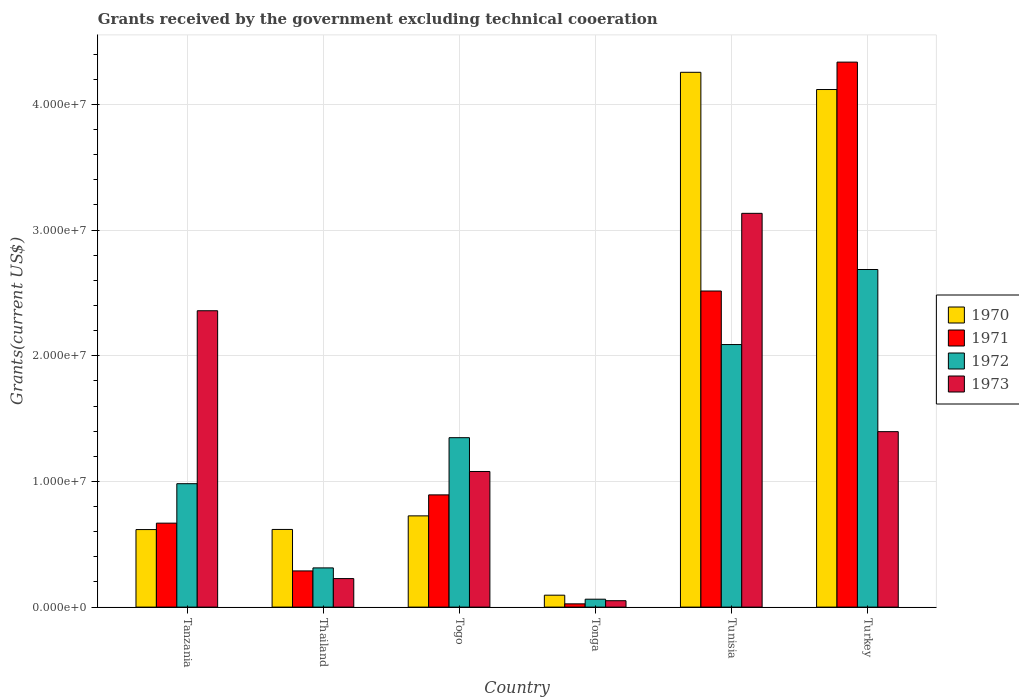How many different coloured bars are there?
Ensure brevity in your answer.  4. Are the number of bars per tick equal to the number of legend labels?
Keep it short and to the point. Yes. How many bars are there on the 2nd tick from the left?
Offer a terse response. 4. How many bars are there on the 5th tick from the right?
Provide a succinct answer. 4. What is the label of the 3rd group of bars from the left?
Keep it short and to the point. Togo. In how many cases, is the number of bars for a given country not equal to the number of legend labels?
Your answer should be very brief. 0. What is the total grants received by the government in 1971 in Tunisia?
Offer a terse response. 2.52e+07. Across all countries, what is the maximum total grants received by the government in 1971?
Your response must be concise. 4.34e+07. Across all countries, what is the minimum total grants received by the government in 1970?
Your response must be concise. 9.50e+05. In which country was the total grants received by the government in 1970 maximum?
Provide a succinct answer. Tunisia. In which country was the total grants received by the government in 1973 minimum?
Ensure brevity in your answer.  Tonga. What is the total total grants received by the government in 1970 in the graph?
Offer a terse response. 1.04e+08. What is the difference between the total grants received by the government in 1971 in Thailand and that in Tunisia?
Offer a very short reply. -2.23e+07. What is the difference between the total grants received by the government in 1970 in Tonga and the total grants received by the government in 1971 in Tunisia?
Your answer should be compact. -2.42e+07. What is the average total grants received by the government in 1973 per country?
Provide a succinct answer. 1.37e+07. In how many countries, is the total grants received by the government in 1970 greater than 30000000 US$?
Your response must be concise. 2. What is the ratio of the total grants received by the government in 1972 in Tanzania to that in Togo?
Your answer should be compact. 0.73. What is the difference between the highest and the second highest total grants received by the government in 1973?
Keep it short and to the point. 1.74e+07. What is the difference between the highest and the lowest total grants received by the government in 1971?
Your answer should be very brief. 4.31e+07. In how many countries, is the total grants received by the government in 1971 greater than the average total grants received by the government in 1971 taken over all countries?
Your answer should be compact. 2. Is it the case that in every country, the sum of the total grants received by the government in 1973 and total grants received by the government in 1972 is greater than the sum of total grants received by the government in 1970 and total grants received by the government in 1971?
Offer a very short reply. No. What does the 1st bar from the right in Tanzania represents?
Offer a terse response. 1973. Is it the case that in every country, the sum of the total grants received by the government in 1970 and total grants received by the government in 1971 is greater than the total grants received by the government in 1973?
Keep it short and to the point. No. How many bars are there?
Keep it short and to the point. 24. How many countries are there in the graph?
Offer a terse response. 6. Are the values on the major ticks of Y-axis written in scientific E-notation?
Give a very brief answer. Yes. Does the graph contain any zero values?
Offer a very short reply. No. How are the legend labels stacked?
Your answer should be very brief. Vertical. What is the title of the graph?
Offer a very short reply. Grants received by the government excluding technical cooeration. What is the label or title of the Y-axis?
Keep it short and to the point. Grants(current US$). What is the Grants(current US$) of 1970 in Tanzania?
Give a very brief answer. 6.17e+06. What is the Grants(current US$) in 1971 in Tanzania?
Keep it short and to the point. 6.68e+06. What is the Grants(current US$) in 1972 in Tanzania?
Your answer should be compact. 9.82e+06. What is the Grants(current US$) in 1973 in Tanzania?
Make the answer very short. 2.36e+07. What is the Grants(current US$) in 1970 in Thailand?
Your answer should be compact. 6.18e+06. What is the Grants(current US$) in 1971 in Thailand?
Ensure brevity in your answer.  2.88e+06. What is the Grants(current US$) in 1972 in Thailand?
Your response must be concise. 3.12e+06. What is the Grants(current US$) in 1973 in Thailand?
Provide a short and direct response. 2.27e+06. What is the Grants(current US$) of 1970 in Togo?
Make the answer very short. 7.26e+06. What is the Grants(current US$) of 1971 in Togo?
Give a very brief answer. 8.93e+06. What is the Grants(current US$) in 1972 in Togo?
Offer a very short reply. 1.35e+07. What is the Grants(current US$) in 1973 in Togo?
Offer a terse response. 1.08e+07. What is the Grants(current US$) of 1970 in Tonga?
Offer a terse response. 9.50e+05. What is the Grants(current US$) in 1971 in Tonga?
Your answer should be compact. 2.60e+05. What is the Grants(current US$) of 1972 in Tonga?
Keep it short and to the point. 6.30e+05. What is the Grants(current US$) of 1973 in Tonga?
Your response must be concise. 5.10e+05. What is the Grants(current US$) in 1970 in Tunisia?
Ensure brevity in your answer.  4.26e+07. What is the Grants(current US$) in 1971 in Tunisia?
Your answer should be very brief. 2.52e+07. What is the Grants(current US$) in 1972 in Tunisia?
Give a very brief answer. 2.09e+07. What is the Grants(current US$) of 1973 in Tunisia?
Offer a terse response. 3.13e+07. What is the Grants(current US$) in 1970 in Turkey?
Provide a succinct answer. 4.12e+07. What is the Grants(current US$) in 1971 in Turkey?
Your response must be concise. 4.34e+07. What is the Grants(current US$) of 1972 in Turkey?
Offer a very short reply. 2.69e+07. What is the Grants(current US$) of 1973 in Turkey?
Offer a very short reply. 1.40e+07. Across all countries, what is the maximum Grants(current US$) of 1970?
Keep it short and to the point. 4.26e+07. Across all countries, what is the maximum Grants(current US$) in 1971?
Make the answer very short. 4.34e+07. Across all countries, what is the maximum Grants(current US$) of 1972?
Make the answer very short. 2.69e+07. Across all countries, what is the maximum Grants(current US$) in 1973?
Offer a very short reply. 3.13e+07. Across all countries, what is the minimum Grants(current US$) in 1970?
Offer a very short reply. 9.50e+05. Across all countries, what is the minimum Grants(current US$) in 1972?
Your answer should be compact. 6.30e+05. Across all countries, what is the minimum Grants(current US$) in 1973?
Your answer should be compact. 5.10e+05. What is the total Grants(current US$) of 1970 in the graph?
Your answer should be very brief. 1.04e+08. What is the total Grants(current US$) of 1971 in the graph?
Ensure brevity in your answer.  8.73e+07. What is the total Grants(current US$) of 1972 in the graph?
Your response must be concise. 7.48e+07. What is the total Grants(current US$) of 1973 in the graph?
Offer a very short reply. 8.24e+07. What is the difference between the Grants(current US$) of 1971 in Tanzania and that in Thailand?
Your response must be concise. 3.80e+06. What is the difference between the Grants(current US$) of 1972 in Tanzania and that in Thailand?
Provide a succinct answer. 6.70e+06. What is the difference between the Grants(current US$) in 1973 in Tanzania and that in Thailand?
Offer a terse response. 2.13e+07. What is the difference between the Grants(current US$) of 1970 in Tanzania and that in Togo?
Your answer should be compact. -1.09e+06. What is the difference between the Grants(current US$) of 1971 in Tanzania and that in Togo?
Keep it short and to the point. -2.25e+06. What is the difference between the Grants(current US$) of 1972 in Tanzania and that in Togo?
Ensure brevity in your answer.  -3.66e+06. What is the difference between the Grants(current US$) in 1973 in Tanzania and that in Togo?
Your response must be concise. 1.28e+07. What is the difference between the Grants(current US$) in 1970 in Tanzania and that in Tonga?
Your response must be concise. 5.22e+06. What is the difference between the Grants(current US$) of 1971 in Tanzania and that in Tonga?
Keep it short and to the point. 6.42e+06. What is the difference between the Grants(current US$) of 1972 in Tanzania and that in Tonga?
Your answer should be compact. 9.19e+06. What is the difference between the Grants(current US$) of 1973 in Tanzania and that in Tonga?
Keep it short and to the point. 2.31e+07. What is the difference between the Grants(current US$) in 1970 in Tanzania and that in Tunisia?
Provide a succinct answer. -3.64e+07. What is the difference between the Grants(current US$) of 1971 in Tanzania and that in Tunisia?
Your answer should be very brief. -1.85e+07. What is the difference between the Grants(current US$) in 1972 in Tanzania and that in Tunisia?
Offer a terse response. -1.11e+07. What is the difference between the Grants(current US$) of 1973 in Tanzania and that in Tunisia?
Your answer should be very brief. -7.75e+06. What is the difference between the Grants(current US$) in 1970 in Tanzania and that in Turkey?
Offer a terse response. -3.50e+07. What is the difference between the Grants(current US$) of 1971 in Tanzania and that in Turkey?
Offer a terse response. -3.67e+07. What is the difference between the Grants(current US$) in 1972 in Tanzania and that in Turkey?
Provide a short and direct response. -1.70e+07. What is the difference between the Grants(current US$) in 1973 in Tanzania and that in Turkey?
Provide a succinct answer. 9.62e+06. What is the difference between the Grants(current US$) of 1970 in Thailand and that in Togo?
Your answer should be compact. -1.08e+06. What is the difference between the Grants(current US$) in 1971 in Thailand and that in Togo?
Your answer should be very brief. -6.05e+06. What is the difference between the Grants(current US$) in 1972 in Thailand and that in Togo?
Your answer should be very brief. -1.04e+07. What is the difference between the Grants(current US$) of 1973 in Thailand and that in Togo?
Your answer should be very brief. -8.52e+06. What is the difference between the Grants(current US$) of 1970 in Thailand and that in Tonga?
Provide a short and direct response. 5.23e+06. What is the difference between the Grants(current US$) of 1971 in Thailand and that in Tonga?
Provide a succinct answer. 2.62e+06. What is the difference between the Grants(current US$) of 1972 in Thailand and that in Tonga?
Offer a terse response. 2.49e+06. What is the difference between the Grants(current US$) in 1973 in Thailand and that in Tonga?
Provide a short and direct response. 1.76e+06. What is the difference between the Grants(current US$) in 1970 in Thailand and that in Tunisia?
Your response must be concise. -3.64e+07. What is the difference between the Grants(current US$) in 1971 in Thailand and that in Tunisia?
Your response must be concise. -2.23e+07. What is the difference between the Grants(current US$) in 1972 in Thailand and that in Tunisia?
Provide a succinct answer. -1.78e+07. What is the difference between the Grants(current US$) of 1973 in Thailand and that in Tunisia?
Keep it short and to the point. -2.91e+07. What is the difference between the Grants(current US$) in 1970 in Thailand and that in Turkey?
Offer a very short reply. -3.50e+07. What is the difference between the Grants(current US$) of 1971 in Thailand and that in Turkey?
Provide a short and direct response. -4.05e+07. What is the difference between the Grants(current US$) in 1972 in Thailand and that in Turkey?
Your answer should be very brief. -2.37e+07. What is the difference between the Grants(current US$) of 1973 in Thailand and that in Turkey?
Your answer should be compact. -1.17e+07. What is the difference between the Grants(current US$) in 1970 in Togo and that in Tonga?
Offer a very short reply. 6.31e+06. What is the difference between the Grants(current US$) in 1971 in Togo and that in Tonga?
Offer a very short reply. 8.67e+06. What is the difference between the Grants(current US$) in 1972 in Togo and that in Tonga?
Make the answer very short. 1.28e+07. What is the difference between the Grants(current US$) in 1973 in Togo and that in Tonga?
Your answer should be compact. 1.03e+07. What is the difference between the Grants(current US$) in 1970 in Togo and that in Tunisia?
Your answer should be very brief. -3.53e+07. What is the difference between the Grants(current US$) of 1971 in Togo and that in Tunisia?
Give a very brief answer. -1.62e+07. What is the difference between the Grants(current US$) of 1972 in Togo and that in Tunisia?
Give a very brief answer. -7.41e+06. What is the difference between the Grants(current US$) in 1973 in Togo and that in Tunisia?
Your answer should be very brief. -2.05e+07. What is the difference between the Grants(current US$) of 1970 in Togo and that in Turkey?
Give a very brief answer. -3.39e+07. What is the difference between the Grants(current US$) of 1971 in Togo and that in Turkey?
Provide a short and direct response. -3.44e+07. What is the difference between the Grants(current US$) in 1972 in Togo and that in Turkey?
Make the answer very short. -1.34e+07. What is the difference between the Grants(current US$) in 1973 in Togo and that in Turkey?
Your answer should be very brief. -3.17e+06. What is the difference between the Grants(current US$) of 1970 in Tonga and that in Tunisia?
Ensure brevity in your answer.  -4.16e+07. What is the difference between the Grants(current US$) of 1971 in Tonga and that in Tunisia?
Your answer should be very brief. -2.49e+07. What is the difference between the Grants(current US$) in 1972 in Tonga and that in Tunisia?
Provide a succinct answer. -2.03e+07. What is the difference between the Grants(current US$) in 1973 in Tonga and that in Tunisia?
Your answer should be very brief. -3.08e+07. What is the difference between the Grants(current US$) of 1970 in Tonga and that in Turkey?
Make the answer very short. -4.02e+07. What is the difference between the Grants(current US$) in 1971 in Tonga and that in Turkey?
Offer a terse response. -4.31e+07. What is the difference between the Grants(current US$) of 1972 in Tonga and that in Turkey?
Your answer should be very brief. -2.62e+07. What is the difference between the Grants(current US$) of 1973 in Tonga and that in Turkey?
Provide a succinct answer. -1.34e+07. What is the difference between the Grants(current US$) of 1970 in Tunisia and that in Turkey?
Give a very brief answer. 1.37e+06. What is the difference between the Grants(current US$) of 1971 in Tunisia and that in Turkey?
Ensure brevity in your answer.  -1.82e+07. What is the difference between the Grants(current US$) in 1972 in Tunisia and that in Turkey?
Make the answer very short. -5.97e+06. What is the difference between the Grants(current US$) of 1973 in Tunisia and that in Turkey?
Offer a very short reply. 1.74e+07. What is the difference between the Grants(current US$) of 1970 in Tanzania and the Grants(current US$) of 1971 in Thailand?
Offer a very short reply. 3.29e+06. What is the difference between the Grants(current US$) of 1970 in Tanzania and the Grants(current US$) of 1972 in Thailand?
Make the answer very short. 3.05e+06. What is the difference between the Grants(current US$) of 1970 in Tanzania and the Grants(current US$) of 1973 in Thailand?
Ensure brevity in your answer.  3.90e+06. What is the difference between the Grants(current US$) of 1971 in Tanzania and the Grants(current US$) of 1972 in Thailand?
Offer a terse response. 3.56e+06. What is the difference between the Grants(current US$) in 1971 in Tanzania and the Grants(current US$) in 1973 in Thailand?
Your answer should be very brief. 4.41e+06. What is the difference between the Grants(current US$) in 1972 in Tanzania and the Grants(current US$) in 1973 in Thailand?
Keep it short and to the point. 7.55e+06. What is the difference between the Grants(current US$) of 1970 in Tanzania and the Grants(current US$) of 1971 in Togo?
Keep it short and to the point. -2.76e+06. What is the difference between the Grants(current US$) in 1970 in Tanzania and the Grants(current US$) in 1972 in Togo?
Ensure brevity in your answer.  -7.31e+06. What is the difference between the Grants(current US$) of 1970 in Tanzania and the Grants(current US$) of 1973 in Togo?
Make the answer very short. -4.62e+06. What is the difference between the Grants(current US$) in 1971 in Tanzania and the Grants(current US$) in 1972 in Togo?
Your answer should be very brief. -6.80e+06. What is the difference between the Grants(current US$) in 1971 in Tanzania and the Grants(current US$) in 1973 in Togo?
Provide a succinct answer. -4.11e+06. What is the difference between the Grants(current US$) in 1972 in Tanzania and the Grants(current US$) in 1973 in Togo?
Offer a terse response. -9.70e+05. What is the difference between the Grants(current US$) in 1970 in Tanzania and the Grants(current US$) in 1971 in Tonga?
Offer a terse response. 5.91e+06. What is the difference between the Grants(current US$) of 1970 in Tanzania and the Grants(current US$) of 1972 in Tonga?
Give a very brief answer. 5.54e+06. What is the difference between the Grants(current US$) of 1970 in Tanzania and the Grants(current US$) of 1973 in Tonga?
Your answer should be compact. 5.66e+06. What is the difference between the Grants(current US$) in 1971 in Tanzania and the Grants(current US$) in 1972 in Tonga?
Offer a very short reply. 6.05e+06. What is the difference between the Grants(current US$) in 1971 in Tanzania and the Grants(current US$) in 1973 in Tonga?
Provide a succinct answer. 6.17e+06. What is the difference between the Grants(current US$) of 1972 in Tanzania and the Grants(current US$) of 1973 in Tonga?
Ensure brevity in your answer.  9.31e+06. What is the difference between the Grants(current US$) of 1970 in Tanzania and the Grants(current US$) of 1971 in Tunisia?
Give a very brief answer. -1.90e+07. What is the difference between the Grants(current US$) of 1970 in Tanzania and the Grants(current US$) of 1972 in Tunisia?
Keep it short and to the point. -1.47e+07. What is the difference between the Grants(current US$) of 1970 in Tanzania and the Grants(current US$) of 1973 in Tunisia?
Ensure brevity in your answer.  -2.52e+07. What is the difference between the Grants(current US$) in 1971 in Tanzania and the Grants(current US$) in 1972 in Tunisia?
Provide a short and direct response. -1.42e+07. What is the difference between the Grants(current US$) in 1971 in Tanzania and the Grants(current US$) in 1973 in Tunisia?
Provide a short and direct response. -2.46e+07. What is the difference between the Grants(current US$) in 1972 in Tanzania and the Grants(current US$) in 1973 in Tunisia?
Offer a terse response. -2.15e+07. What is the difference between the Grants(current US$) in 1970 in Tanzania and the Grants(current US$) in 1971 in Turkey?
Keep it short and to the point. -3.72e+07. What is the difference between the Grants(current US$) in 1970 in Tanzania and the Grants(current US$) in 1972 in Turkey?
Your answer should be compact. -2.07e+07. What is the difference between the Grants(current US$) of 1970 in Tanzania and the Grants(current US$) of 1973 in Turkey?
Provide a short and direct response. -7.79e+06. What is the difference between the Grants(current US$) in 1971 in Tanzania and the Grants(current US$) in 1972 in Turkey?
Keep it short and to the point. -2.02e+07. What is the difference between the Grants(current US$) of 1971 in Tanzania and the Grants(current US$) of 1973 in Turkey?
Offer a very short reply. -7.28e+06. What is the difference between the Grants(current US$) in 1972 in Tanzania and the Grants(current US$) in 1973 in Turkey?
Offer a terse response. -4.14e+06. What is the difference between the Grants(current US$) of 1970 in Thailand and the Grants(current US$) of 1971 in Togo?
Provide a succinct answer. -2.75e+06. What is the difference between the Grants(current US$) of 1970 in Thailand and the Grants(current US$) of 1972 in Togo?
Keep it short and to the point. -7.30e+06. What is the difference between the Grants(current US$) in 1970 in Thailand and the Grants(current US$) in 1973 in Togo?
Your response must be concise. -4.61e+06. What is the difference between the Grants(current US$) of 1971 in Thailand and the Grants(current US$) of 1972 in Togo?
Keep it short and to the point. -1.06e+07. What is the difference between the Grants(current US$) of 1971 in Thailand and the Grants(current US$) of 1973 in Togo?
Your answer should be compact. -7.91e+06. What is the difference between the Grants(current US$) in 1972 in Thailand and the Grants(current US$) in 1973 in Togo?
Offer a terse response. -7.67e+06. What is the difference between the Grants(current US$) in 1970 in Thailand and the Grants(current US$) in 1971 in Tonga?
Give a very brief answer. 5.92e+06. What is the difference between the Grants(current US$) in 1970 in Thailand and the Grants(current US$) in 1972 in Tonga?
Ensure brevity in your answer.  5.55e+06. What is the difference between the Grants(current US$) in 1970 in Thailand and the Grants(current US$) in 1973 in Tonga?
Offer a terse response. 5.67e+06. What is the difference between the Grants(current US$) in 1971 in Thailand and the Grants(current US$) in 1972 in Tonga?
Ensure brevity in your answer.  2.25e+06. What is the difference between the Grants(current US$) in 1971 in Thailand and the Grants(current US$) in 1973 in Tonga?
Provide a short and direct response. 2.37e+06. What is the difference between the Grants(current US$) in 1972 in Thailand and the Grants(current US$) in 1973 in Tonga?
Your answer should be very brief. 2.61e+06. What is the difference between the Grants(current US$) in 1970 in Thailand and the Grants(current US$) in 1971 in Tunisia?
Your answer should be very brief. -1.90e+07. What is the difference between the Grants(current US$) of 1970 in Thailand and the Grants(current US$) of 1972 in Tunisia?
Ensure brevity in your answer.  -1.47e+07. What is the difference between the Grants(current US$) of 1970 in Thailand and the Grants(current US$) of 1973 in Tunisia?
Keep it short and to the point. -2.52e+07. What is the difference between the Grants(current US$) in 1971 in Thailand and the Grants(current US$) in 1972 in Tunisia?
Provide a short and direct response. -1.80e+07. What is the difference between the Grants(current US$) in 1971 in Thailand and the Grants(current US$) in 1973 in Tunisia?
Your answer should be compact. -2.84e+07. What is the difference between the Grants(current US$) in 1972 in Thailand and the Grants(current US$) in 1973 in Tunisia?
Your answer should be very brief. -2.82e+07. What is the difference between the Grants(current US$) in 1970 in Thailand and the Grants(current US$) in 1971 in Turkey?
Provide a succinct answer. -3.72e+07. What is the difference between the Grants(current US$) in 1970 in Thailand and the Grants(current US$) in 1972 in Turkey?
Ensure brevity in your answer.  -2.07e+07. What is the difference between the Grants(current US$) in 1970 in Thailand and the Grants(current US$) in 1973 in Turkey?
Your answer should be compact. -7.78e+06. What is the difference between the Grants(current US$) in 1971 in Thailand and the Grants(current US$) in 1972 in Turkey?
Offer a very short reply. -2.40e+07. What is the difference between the Grants(current US$) of 1971 in Thailand and the Grants(current US$) of 1973 in Turkey?
Your response must be concise. -1.11e+07. What is the difference between the Grants(current US$) of 1972 in Thailand and the Grants(current US$) of 1973 in Turkey?
Your response must be concise. -1.08e+07. What is the difference between the Grants(current US$) of 1970 in Togo and the Grants(current US$) of 1972 in Tonga?
Keep it short and to the point. 6.63e+06. What is the difference between the Grants(current US$) in 1970 in Togo and the Grants(current US$) in 1973 in Tonga?
Your response must be concise. 6.75e+06. What is the difference between the Grants(current US$) of 1971 in Togo and the Grants(current US$) of 1972 in Tonga?
Provide a succinct answer. 8.30e+06. What is the difference between the Grants(current US$) in 1971 in Togo and the Grants(current US$) in 1973 in Tonga?
Ensure brevity in your answer.  8.42e+06. What is the difference between the Grants(current US$) in 1972 in Togo and the Grants(current US$) in 1973 in Tonga?
Give a very brief answer. 1.30e+07. What is the difference between the Grants(current US$) of 1970 in Togo and the Grants(current US$) of 1971 in Tunisia?
Your answer should be compact. -1.79e+07. What is the difference between the Grants(current US$) of 1970 in Togo and the Grants(current US$) of 1972 in Tunisia?
Provide a short and direct response. -1.36e+07. What is the difference between the Grants(current US$) of 1970 in Togo and the Grants(current US$) of 1973 in Tunisia?
Your response must be concise. -2.41e+07. What is the difference between the Grants(current US$) in 1971 in Togo and the Grants(current US$) in 1972 in Tunisia?
Provide a succinct answer. -1.20e+07. What is the difference between the Grants(current US$) of 1971 in Togo and the Grants(current US$) of 1973 in Tunisia?
Keep it short and to the point. -2.24e+07. What is the difference between the Grants(current US$) in 1972 in Togo and the Grants(current US$) in 1973 in Tunisia?
Keep it short and to the point. -1.78e+07. What is the difference between the Grants(current US$) of 1970 in Togo and the Grants(current US$) of 1971 in Turkey?
Give a very brief answer. -3.61e+07. What is the difference between the Grants(current US$) of 1970 in Togo and the Grants(current US$) of 1972 in Turkey?
Provide a short and direct response. -1.96e+07. What is the difference between the Grants(current US$) of 1970 in Togo and the Grants(current US$) of 1973 in Turkey?
Your response must be concise. -6.70e+06. What is the difference between the Grants(current US$) of 1971 in Togo and the Grants(current US$) of 1972 in Turkey?
Offer a very short reply. -1.79e+07. What is the difference between the Grants(current US$) of 1971 in Togo and the Grants(current US$) of 1973 in Turkey?
Provide a succinct answer. -5.03e+06. What is the difference between the Grants(current US$) of 1972 in Togo and the Grants(current US$) of 1973 in Turkey?
Provide a short and direct response. -4.80e+05. What is the difference between the Grants(current US$) in 1970 in Tonga and the Grants(current US$) in 1971 in Tunisia?
Your answer should be compact. -2.42e+07. What is the difference between the Grants(current US$) in 1970 in Tonga and the Grants(current US$) in 1972 in Tunisia?
Offer a very short reply. -1.99e+07. What is the difference between the Grants(current US$) in 1970 in Tonga and the Grants(current US$) in 1973 in Tunisia?
Provide a succinct answer. -3.04e+07. What is the difference between the Grants(current US$) of 1971 in Tonga and the Grants(current US$) of 1972 in Tunisia?
Ensure brevity in your answer.  -2.06e+07. What is the difference between the Grants(current US$) of 1971 in Tonga and the Grants(current US$) of 1973 in Tunisia?
Provide a succinct answer. -3.11e+07. What is the difference between the Grants(current US$) of 1972 in Tonga and the Grants(current US$) of 1973 in Tunisia?
Provide a short and direct response. -3.07e+07. What is the difference between the Grants(current US$) of 1970 in Tonga and the Grants(current US$) of 1971 in Turkey?
Your answer should be very brief. -4.24e+07. What is the difference between the Grants(current US$) of 1970 in Tonga and the Grants(current US$) of 1972 in Turkey?
Your response must be concise. -2.59e+07. What is the difference between the Grants(current US$) in 1970 in Tonga and the Grants(current US$) in 1973 in Turkey?
Keep it short and to the point. -1.30e+07. What is the difference between the Grants(current US$) of 1971 in Tonga and the Grants(current US$) of 1972 in Turkey?
Keep it short and to the point. -2.66e+07. What is the difference between the Grants(current US$) in 1971 in Tonga and the Grants(current US$) in 1973 in Turkey?
Provide a succinct answer. -1.37e+07. What is the difference between the Grants(current US$) of 1972 in Tonga and the Grants(current US$) of 1973 in Turkey?
Provide a short and direct response. -1.33e+07. What is the difference between the Grants(current US$) in 1970 in Tunisia and the Grants(current US$) in 1971 in Turkey?
Give a very brief answer. -8.10e+05. What is the difference between the Grants(current US$) of 1970 in Tunisia and the Grants(current US$) of 1972 in Turkey?
Offer a very short reply. 1.57e+07. What is the difference between the Grants(current US$) in 1970 in Tunisia and the Grants(current US$) in 1973 in Turkey?
Your answer should be very brief. 2.86e+07. What is the difference between the Grants(current US$) in 1971 in Tunisia and the Grants(current US$) in 1972 in Turkey?
Your answer should be very brief. -1.71e+06. What is the difference between the Grants(current US$) in 1971 in Tunisia and the Grants(current US$) in 1973 in Turkey?
Offer a terse response. 1.12e+07. What is the difference between the Grants(current US$) of 1972 in Tunisia and the Grants(current US$) of 1973 in Turkey?
Your answer should be very brief. 6.93e+06. What is the average Grants(current US$) of 1970 per country?
Give a very brief answer. 1.74e+07. What is the average Grants(current US$) of 1971 per country?
Make the answer very short. 1.45e+07. What is the average Grants(current US$) of 1972 per country?
Your response must be concise. 1.25e+07. What is the average Grants(current US$) in 1973 per country?
Your answer should be very brief. 1.37e+07. What is the difference between the Grants(current US$) in 1970 and Grants(current US$) in 1971 in Tanzania?
Offer a very short reply. -5.10e+05. What is the difference between the Grants(current US$) in 1970 and Grants(current US$) in 1972 in Tanzania?
Keep it short and to the point. -3.65e+06. What is the difference between the Grants(current US$) in 1970 and Grants(current US$) in 1973 in Tanzania?
Keep it short and to the point. -1.74e+07. What is the difference between the Grants(current US$) in 1971 and Grants(current US$) in 1972 in Tanzania?
Offer a terse response. -3.14e+06. What is the difference between the Grants(current US$) in 1971 and Grants(current US$) in 1973 in Tanzania?
Provide a short and direct response. -1.69e+07. What is the difference between the Grants(current US$) in 1972 and Grants(current US$) in 1973 in Tanzania?
Provide a succinct answer. -1.38e+07. What is the difference between the Grants(current US$) in 1970 and Grants(current US$) in 1971 in Thailand?
Make the answer very short. 3.30e+06. What is the difference between the Grants(current US$) of 1970 and Grants(current US$) of 1972 in Thailand?
Your answer should be very brief. 3.06e+06. What is the difference between the Grants(current US$) in 1970 and Grants(current US$) in 1973 in Thailand?
Your answer should be compact. 3.91e+06. What is the difference between the Grants(current US$) in 1971 and Grants(current US$) in 1973 in Thailand?
Keep it short and to the point. 6.10e+05. What is the difference between the Grants(current US$) of 1972 and Grants(current US$) of 1973 in Thailand?
Offer a very short reply. 8.50e+05. What is the difference between the Grants(current US$) in 1970 and Grants(current US$) in 1971 in Togo?
Offer a very short reply. -1.67e+06. What is the difference between the Grants(current US$) of 1970 and Grants(current US$) of 1972 in Togo?
Ensure brevity in your answer.  -6.22e+06. What is the difference between the Grants(current US$) in 1970 and Grants(current US$) in 1973 in Togo?
Provide a succinct answer. -3.53e+06. What is the difference between the Grants(current US$) in 1971 and Grants(current US$) in 1972 in Togo?
Ensure brevity in your answer.  -4.55e+06. What is the difference between the Grants(current US$) of 1971 and Grants(current US$) of 1973 in Togo?
Your answer should be compact. -1.86e+06. What is the difference between the Grants(current US$) of 1972 and Grants(current US$) of 1973 in Togo?
Provide a short and direct response. 2.69e+06. What is the difference between the Grants(current US$) of 1970 and Grants(current US$) of 1971 in Tonga?
Offer a terse response. 6.90e+05. What is the difference between the Grants(current US$) in 1970 and Grants(current US$) in 1972 in Tonga?
Your response must be concise. 3.20e+05. What is the difference between the Grants(current US$) of 1971 and Grants(current US$) of 1972 in Tonga?
Your response must be concise. -3.70e+05. What is the difference between the Grants(current US$) of 1971 and Grants(current US$) of 1973 in Tonga?
Give a very brief answer. -2.50e+05. What is the difference between the Grants(current US$) in 1970 and Grants(current US$) in 1971 in Tunisia?
Make the answer very short. 1.74e+07. What is the difference between the Grants(current US$) of 1970 and Grants(current US$) of 1972 in Tunisia?
Offer a terse response. 2.17e+07. What is the difference between the Grants(current US$) in 1970 and Grants(current US$) in 1973 in Tunisia?
Your answer should be compact. 1.12e+07. What is the difference between the Grants(current US$) in 1971 and Grants(current US$) in 1972 in Tunisia?
Keep it short and to the point. 4.26e+06. What is the difference between the Grants(current US$) in 1971 and Grants(current US$) in 1973 in Tunisia?
Give a very brief answer. -6.18e+06. What is the difference between the Grants(current US$) in 1972 and Grants(current US$) in 1973 in Tunisia?
Provide a short and direct response. -1.04e+07. What is the difference between the Grants(current US$) of 1970 and Grants(current US$) of 1971 in Turkey?
Offer a very short reply. -2.18e+06. What is the difference between the Grants(current US$) of 1970 and Grants(current US$) of 1972 in Turkey?
Your answer should be very brief. 1.43e+07. What is the difference between the Grants(current US$) of 1970 and Grants(current US$) of 1973 in Turkey?
Ensure brevity in your answer.  2.72e+07. What is the difference between the Grants(current US$) in 1971 and Grants(current US$) in 1972 in Turkey?
Offer a terse response. 1.65e+07. What is the difference between the Grants(current US$) in 1971 and Grants(current US$) in 1973 in Turkey?
Offer a terse response. 2.94e+07. What is the difference between the Grants(current US$) of 1972 and Grants(current US$) of 1973 in Turkey?
Your answer should be very brief. 1.29e+07. What is the ratio of the Grants(current US$) of 1971 in Tanzania to that in Thailand?
Give a very brief answer. 2.32. What is the ratio of the Grants(current US$) in 1972 in Tanzania to that in Thailand?
Your response must be concise. 3.15. What is the ratio of the Grants(current US$) of 1973 in Tanzania to that in Thailand?
Your answer should be compact. 10.39. What is the ratio of the Grants(current US$) of 1970 in Tanzania to that in Togo?
Offer a terse response. 0.85. What is the ratio of the Grants(current US$) in 1971 in Tanzania to that in Togo?
Ensure brevity in your answer.  0.75. What is the ratio of the Grants(current US$) in 1972 in Tanzania to that in Togo?
Keep it short and to the point. 0.73. What is the ratio of the Grants(current US$) in 1973 in Tanzania to that in Togo?
Your response must be concise. 2.19. What is the ratio of the Grants(current US$) of 1970 in Tanzania to that in Tonga?
Offer a terse response. 6.49. What is the ratio of the Grants(current US$) of 1971 in Tanzania to that in Tonga?
Give a very brief answer. 25.69. What is the ratio of the Grants(current US$) in 1972 in Tanzania to that in Tonga?
Your answer should be compact. 15.59. What is the ratio of the Grants(current US$) in 1973 in Tanzania to that in Tonga?
Keep it short and to the point. 46.24. What is the ratio of the Grants(current US$) in 1970 in Tanzania to that in Tunisia?
Your answer should be compact. 0.14. What is the ratio of the Grants(current US$) of 1971 in Tanzania to that in Tunisia?
Offer a very short reply. 0.27. What is the ratio of the Grants(current US$) in 1972 in Tanzania to that in Tunisia?
Your response must be concise. 0.47. What is the ratio of the Grants(current US$) of 1973 in Tanzania to that in Tunisia?
Provide a succinct answer. 0.75. What is the ratio of the Grants(current US$) in 1970 in Tanzania to that in Turkey?
Offer a terse response. 0.15. What is the ratio of the Grants(current US$) of 1971 in Tanzania to that in Turkey?
Ensure brevity in your answer.  0.15. What is the ratio of the Grants(current US$) of 1972 in Tanzania to that in Turkey?
Make the answer very short. 0.37. What is the ratio of the Grants(current US$) in 1973 in Tanzania to that in Turkey?
Your answer should be very brief. 1.69. What is the ratio of the Grants(current US$) in 1970 in Thailand to that in Togo?
Ensure brevity in your answer.  0.85. What is the ratio of the Grants(current US$) of 1971 in Thailand to that in Togo?
Offer a terse response. 0.32. What is the ratio of the Grants(current US$) of 1972 in Thailand to that in Togo?
Offer a very short reply. 0.23. What is the ratio of the Grants(current US$) in 1973 in Thailand to that in Togo?
Your answer should be very brief. 0.21. What is the ratio of the Grants(current US$) of 1970 in Thailand to that in Tonga?
Give a very brief answer. 6.51. What is the ratio of the Grants(current US$) in 1971 in Thailand to that in Tonga?
Offer a terse response. 11.08. What is the ratio of the Grants(current US$) of 1972 in Thailand to that in Tonga?
Provide a short and direct response. 4.95. What is the ratio of the Grants(current US$) of 1973 in Thailand to that in Tonga?
Your response must be concise. 4.45. What is the ratio of the Grants(current US$) in 1970 in Thailand to that in Tunisia?
Keep it short and to the point. 0.15. What is the ratio of the Grants(current US$) of 1971 in Thailand to that in Tunisia?
Make the answer very short. 0.11. What is the ratio of the Grants(current US$) of 1972 in Thailand to that in Tunisia?
Your response must be concise. 0.15. What is the ratio of the Grants(current US$) of 1973 in Thailand to that in Tunisia?
Provide a succinct answer. 0.07. What is the ratio of the Grants(current US$) in 1970 in Thailand to that in Turkey?
Your response must be concise. 0.15. What is the ratio of the Grants(current US$) in 1971 in Thailand to that in Turkey?
Give a very brief answer. 0.07. What is the ratio of the Grants(current US$) in 1972 in Thailand to that in Turkey?
Your answer should be very brief. 0.12. What is the ratio of the Grants(current US$) in 1973 in Thailand to that in Turkey?
Keep it short and to the point. 0.16. What is the ratio of the Grants(current US$) in 1970 in Togo to that in Tonga?
Your answer should be very brief. 7.64. What is the ratio of the Grants(current US$) in 1971 in Togo to that in Tonga?
Keep it short and to the point. 34.35. What is the ratio of the Grants(current US$) in 1972 in Togo to that in Tonga?
Offer a terse response. 21.4. What is the ratio of the Grants(current US$) in 1973 in Togo to that in Tonga?
Provide a short and direct response. 21.16. What is the ratio of the Grants(current US$) in 1970 in Togo to that in Tunisia?
Provide a short and direct response. 0.17. What is the ratio of the Grants(current US$) of 1971 in Togo to that in Tunisia?
Make the answer very short. 0.36. What is the ratio of the Grants(current US$) of 1972 in Togo to that in Tunisia?
Give a very brief answer. 0.65. What is the ratio of the Grants(current US$) of 1973 in Togo to that in Tunisia?
Your answer should be very brief. 0.34. What is the ratio of the Grants(current US$) in 1970 in Togo to that in Turkey?
Provide a short and direct response. 0.18. What is the ratio of the Grants(current US$) of 1971 in Togo to that in Turkey?
Make the answer very short. 0.21. What is the ratio of the Grants(current US$) of 1972 in Togo to that in Turkey?
Your answer should be very brief. 0.5. What is the ratio of the Grants(current US$) of 1973 in Togo to that in Turkey?
Keep it short and to the point. 0.77. What is the ratio of the Grants(current US$) in 1970 in Tonga to that in Tunisia?
Make the answer very short. 0.02. What is the ratio of the Grants(current US$) of 1971 in Tonga to that in Tunisia?
Ensure brevity in your answer.  0.01. What is the ratio of the Grants(current US$) of 1972 in Tonga to that in Tunisia?
Provide a short and direct response. 0.03. What is the ratio of the Grants(current US$) of 1973 in Tonga to that in Tunisia?
Offer a very short reply. 0.02. What is the ratio of the Grants(current US$) in 1970 in Tonga to that in Turkey?
Keep it short and to the point. 0.02. What is the ratio of the Grants(current US$) in 1971 in Tonga to that in Turkey?
Offer a terse response. 0.01. What is the ratio of the Grants(current US$) in 1972 in Tonga to that in Turkey?
Give a very brief answer. 0.02. What is the ratio of the Grants(current US$) in 1973 in Tonga to that in Turkey?
Your answer should be compact. 0.04. What is the ratio of the Grants(current US$) in 1970 in Tunisia to that in Turkey?
Your answer should be compact. 1.03. What is the ratio of the Grants(current US$) of 1971 in Tunisia to that in Turkey?
Provide a short and direct response. 0.58. What is the ratio of the Grants(current US$) of 1972 in Tunisia to that in Turkey?
Keep it short and to the point. 0.78. What is the ratio of the Grants(current US$) of 1973 in Tunisia to that in Turkey?
Offer a terse response. 2.24. What is the difference between the highest and the second highest Grants(current US$) in 1970?
Your answer should be compact. 1.37e+06. What is the difference between the highest and the second highest Grants(current US$) in 1971?
Provide a short and direct response. 1.82e+07. What is the difference between the highest and the second highest Grants(current US$) of 1972?
Provide a succinct answer. 5.97e+06. What is the difference between the highest and the second highest Grants(current US$) of 1973?
Your response must be concise. 7.75e+06. What is the difference between the highest and the lowest Grants(current US$) in 1970?
Your answer should be very brief. 4.16e+07. What is the difference between the highest and the lowest Grants(current US$) of 1971?
Your answer should be very brief. 4.31e+07. What is the difference between the highest and the lowest Grants(current US$) in 1972?
Offer a terse response. 2.62e+07. What is the difference between the highest and the lowest Grants(current US$) in 1973?
Give a very brief answer. 3.08e+07. 